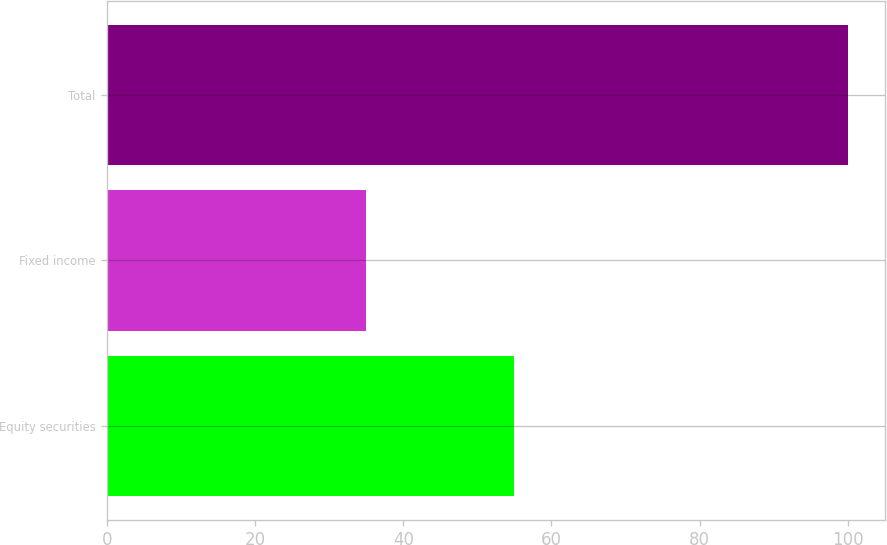Convert chart. <chart><loc_0><loc_0><loc_500><loc_500><bar_chart><fcel>Equity securities<fcel>Fixed income<fcel>Total<nl><fcel>55<fcel>35<fcel>100<nl></chart> 